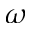Convert formula to latex. <formula><loc_0><loc_0><loc_500><loc_500>\omega</formula> 